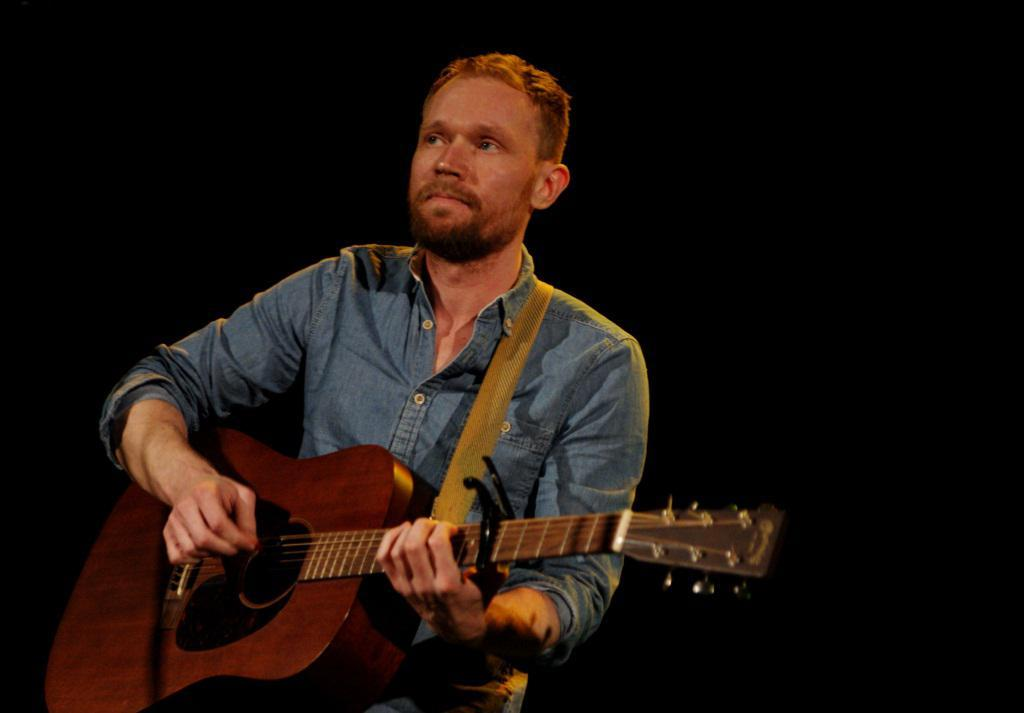Who is the main subject in the image? There is a man in the image. What is the man doing in the image? The man is sitting on a table. What object is the man holding in the image? The man is holding a guitar. What type of insect is crawling on the guitar in the image? There is no insect present in the image. 